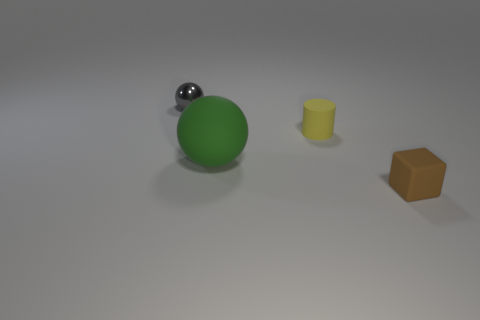Do the object that is on the left side of the green matte thing and the rubber thing left of the small cylinder have the same shape?
Offer a very short reply. Yes. There is a tiny matte object that is on the left side of the object on the right side of the cylinder; how many balls are left of it?
Keep it short and to the point. 2. What material is the object that is in front of the sphere in front of the small thing that is left of the yellow rubber cylinder?
Keep it short and to the point. Rubber. Do the small object that is in front of the rubber cylinder and the small gray thing have the same material?
Offer a terse response. No. How many cylinders have the same size as the green rubber ball?
Your answer should be very brief. 0. Are there more small objects that are on the left side of the small brown matte block than tiny yellow rubber things in front of the green ball?
Provide a succinct answer. Yes. Is there a large rubber thing of the same shape as the tiny gray shiny thing?
Provide a succinct answer. Yes. What size is the sphere in front of the tiny thing to the left of the small yellow rubber object?
Your answer should be compact. Large. There is a tiny object left of the ball in front of the ball to the left of the green sphere; what is its shape?
Your answer should be compact. Sphere. The yellow cylinder that is the same material as the tiny brown thing is what size?
Provide a short and direct response. Small. 